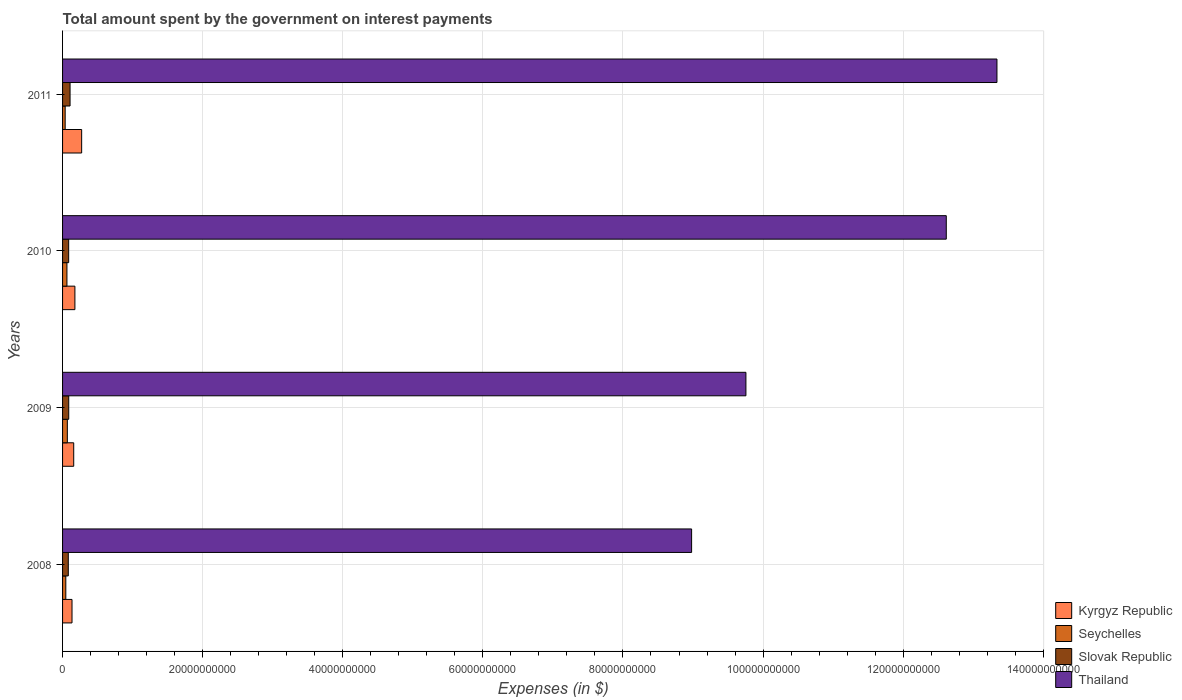Are the number of bars per tick equal to the number of legend labels?
Keep it short and to the point. Yes. Are the number of bars on each tick of the Y-axis equal?
Your response must be concise. Yes. What is the label of the 3rd group of bars from the top?
Your response must be concise. 2009. In how many cases, is the number of bars for a given year not equal to the number of legend labels?
Offer a terse response. 0. What is the amount spent on interest payments by the government in Seychelles in 2009?
Provide a succinct answer. 6.83e+08. Across all years, what is the maximum amount spent on interest payments by the government in Thailand?
Your answer should be very brief. 1.33e+11. Across all years, what is the minimum amount spent on interest payments by the government in Seychelles?
Your response must be concise. 3.72e+08. In which year was the amount spent on interest payments by the government in Seychelles minimum?
Your response must be concise. 2011. What is the total amount spent on interest payments by the government in Kyrgyz Republic in the graph?
Keep it short and to the point. 7.43e+09. What is the difference between the amount spent on interest payments by the government in Thailand in 2008 and that in 2009?
Keep it short and to the point. -7.75e+09. What is the difference between the amount spent on interest payments by the government in Kyrgyz Republic in 2010 and the amount spent on interest payments by the government in Slovak Republic in 2011?
Provide a short and direct response. 6.91e+08. What is the average amount spent on interest payments by the government in Slovak Republic per year?
Your answer should be compact. 9.10e+08. In the year 2008, what is the difference between the amount spent on interest payments by the government in Slovak Republic and amount spent on interest payments by the government in Kyrgyz Republic?
Make the answer very short. -5.30e+08. In how many years, is the amount spent on interest payments by the government in Kyrgyz Republic greater than 8000000000 $?
Your answer should be very brief. 0. What is the ratio of the amount spent on interest payments by the government in Kyrgyz Republic in 2009 to that in 2011?
Your answer should be very brief. 0.58. Is the difference between the amount spent on interest payments by the government in Slovak Republic in 2009 and 2010 greater than the difference between the amount spent on interest payments by the government in Kyrgyz Republic in 2009 and 2010?
Your answer should be very brief. Yes. What is the difference between the highest and the second highest amount spent on interest payments by the government in Slovak Republic?
Keep it short and to the point. 1.91e+08. What is the difference between the highest and the lowest amount spent on interest payments by the government in Thailand?
Give a very brief answer. 4.36e+1. Is the sum of the amount spent on interest payments by the government in Slovak Republic in 2009 and 2010 greater than the maximum amount spent on interest payments by the government in Kyrgyz Republic across all years?
Provide a short and direct response. No. Is it the case that in every year, the sum of the amount spent on interest payments by the government in Seychelles and amount spent on interest payments by the government in Thailand is greater than the sum of amount spent on interest payments by the government in Slovak Republic and amount spent on interest payments by the government in Kyrgyz Republic?
Your answer should be very brief. Yes. What does the 3rd bar from the top in 2010 represents?
Your answer should be compact. Seychelles. What does the 1st bar from the bottom in 2008 represents?
Your answer should be very brief. Kyrgyz Republic. Are all the bars in the graph horizontal?
Ensure brevity in your answer.  Yes. How many years are there in the graph?
Keep it short and to the point. 4. What is the difference between two consecutive major ticks on the X-axis?
Make the answer very short. 2.00e+1. Are the values on the major ticks of X-axis written in scientific E-notation?
Your response must be concise. No. Does the graph contain any zero values?
Provide a succinct answer. No. Does the graph contain grids?
Your answer should be very brief. Yes. What is the title of the graph?
Your answer should be very brief. Total amount spent by the government on interest payments. Does "Armenia" appear as one of the legend labels in the graph?
Your answer should be compact. No. What is the label or title of the X-axis?
Offer a very short reply. Expenses (in $). What is the Expenses (in $) of Kyrgyz Republic in 2008?
Offer a very short reply. 1.35e+09. What is the Expenses (in $) of Seychelles in 2008?
Provide a short and direct response. 4.64e+08. What is the Expenses (in $) in Slovak Republic in 2008?
Keep it short and to the point. 8.18e+08. What is the Expenses (in $) of Thailand in 2008?
Your answer should be very brief. 8.98e+1. What is the Expenses (in $) of Kyrgyz Republic in 2009?
Provide a succinct answer. 1.59e+09. What is the Expenses (in $) in Seychelles in 2009?
Provide a succinct answer. 6.83e+08. What is the Expenses (in $) of Slovak Republic in 2009?
Your response must be concise. 8.80e+08. What is the Expenses (in $) in Thailand in 2009?
Your response must be concise. 9.76e+1. What is the Expenses (in $) of Kyrgyz Republic in 2010?
Make the answer very short. 1.76e+09. What is the Expenses (in $) of Seychelles in 2010?
Your response must be concise. 6.25e+08. What is the Expenses (in $) of Slovak Republic in 2010?
Offer a very short reply. 8.71e+08. What is the Expenses (in $) of Thailand in 2010?
Provide a short and direct response. 1.26e+11. What is the Expenses (in $) of Kyrgyz Republic in 2011?
Your response must be concise. 2.73e+09. What is the Expenses (in $) of Seychelles in 2011?
Make the answer very short. 3.72e+08. What is the Expenses (in $) in Slovak Republic in 2011?
Provide a short and direct response. 1.07e+09. What is the Expenses (in $) in Thailand in 2011?
Give a very brief answer. 1.33e+11. Across all years, what is the maximum Expenses (in $) of Kyrgyz Republic?
Your answer should be very brief. 2.73e+09. Across all years, what is the maximum Expenses (in $) in Seychelles?
Your answer should be compact. 6.83e+08. Across all years, what is the maximum Expenses (in $) of Slovak Republic?
Offer a very short reply. 1.07e+09. Across all years, what is the maximum Expenses (in $) in Thailand?
Offer a terse response. 1.33e+11. Across all years, what is the minimum Expenses (in $) in Kyrgyz Republic?
Provide a short and direct response. 1.35e+09. Across all years, what is the minimum Expenses (in $) of Seychelles?
Offer a very short reply. 3.72e+08. Across all years, what is the minimum Expenses (in $) in Slovak Republic?
Your response must be concise. 8.18e+08. Across all years, what is the minimum Expenses (in $) of Thailand?
Provide a short and direct response. 8.98e+1. What is the total Expenses (in $) of Kyrgyz Republic in the graph?
Offer a terse response. 7.43e+09. What is the total Expenses (in $) in Seychelles in the graph?
Ensure brevity in your answer.  2.14e+09. What is the total Expenses (in $) in Slovak Republic in the graph?
Make the answer very short. 3.64e+09. What is the total Expenses (in $) of Thailand in the graph?
Make the answer very short. 4.47e+11. What is the difference between the Expenses (in $) of Kyrgyz Republic in 2008 and that in 2009?
Offer a terse response. -2.44e+08. What is the difference between the Expenses (in $) in Seychelles in 2008 and that in 2009?
Provide a short and direct response. -2.19e+08. What is the difference between the Expenses (in $) in Slovak Republic in 2008 and that in 2009?
Provide a short and direct response. -6.21e+07. What is the difference between the Expenses (in $) of Thailand in 2008 and that in 2009?
Offer a terse response. -7.75e+09. What is the difference between the Expenses (in $) of Kyrgyz Republic in 2008 and that in 2010?
Your answer should be very brief. -4.13e+08. What is the difference between the Expenses (in $) of Seychelles in 2008 and that in 2010?
Your response must be concise. -1.61e+08. What is the difference between the Expenses (in $) of Slovak Republic in 2008 and that in 2010?
Offer a terse response. -5.28e+07. What is the difference between the Expenses (in $) in Thailand in 2008 and that in 2010?
Your answer should be compact. -3.64e+1. What is the difference between the Expenses (in $) of Kyrgyz Republic in 2008 and that in 2011?
Keep it short and to the point. -1.38e+09. What is the difference between the Expenses (in $) in Seychelles in 2008 and that in 2011?
Offer a terse response. 9.21e+07. What is the difference between the Expenses (in $) in Slovak Republic in 2008 and that in 2011?
Keep it short and to the point. -2.53e+08. What is the difference between the Expenses (in $) in Thailand in 2008 and that in 2011?
Your answer should be compact. -4.36e+1. What is the difference between the Expenses (in $) in Kyrgyz Republic in 2009 and that in 2010?
Ensure brevity in your answer.  -1.69e+08. What is the difference between the Expenses (in $) in Seychelles in 2009 and that in 2010?
Your answer should be compact. 5.77e+07. What is the difference between the Expenses (in $) in Slovak Republic in 2009 and that in 2010?
Provide a short and direct response. 9.30e+06. What is the difference between the Expenses (in $) of Thailand in 2009 and that in 2010?
Your answer should be compact. -2.86e+1. What is the difference between the Expenses (in $) in Kyrgyz Republic in 2009 and that in 2011?
Your response must be concise. -1.13e+09. What is the difference between the Expenses (in $) in Seychelles in 2009 and that in 2011?
Keep it short and to the point. 3.11e+08. What is the difference between the Expenses (in $) in Slovak Republic in 2009 and that in 2011?
Your response must be concise. -1.91e+08. What is the difference between the Expenses (in $) in Thailand in 2009 and that in 2011?
Offer a terse response. -3.58e+1. What is the difference between the Expenses (in $) of Kyrgyz Republic in 2010 and that in 2011?
Offer a very short reply. -9.64e+08. What is the difference between the Expenses (in $) of Seychelles in 2010 and that in 2011?
Give a very brief answer. 2.53e+08. What is the difference between the Expenses (in $) of Slovak Republic in 2010 and that in 2011?
Your answer should be compact. -2.00e+08. What is the difference between the Expenses (in $) of Thailand in 2010 and that in 2011?
Provide a succinct answer. -7.23e+09. What is the difference between the Expenses (in $) of Kyrgyz Republic in 2008 and the Expenses (in $) of Seychelles in 2009?
Make the answer very short. 6.66e+08. What is the difference between the Expenses (in $) of Kyrgyz Republic in 2008 and the Expenses (in $) of Slovak Republic in 2009?
Give a very brief answer. 4.68e+08. What is the difference between the Expenses (in $) of Kyrgyz Republic in 2008 and the Expenses (in $) of Thailand in 2009?
Give a very brief answer. -9.62e+1. What is the difference between the Expenses (in $) in Seychelles in 2008 and the Expenses (in $) in Slovak Republic in 2009?
Provide a short and direct response. -4.16e+08. What is the difference between the Expenses (in $) of Seychelles in 2008 and the Expenses (in $) of Thailand in 2009?
Provide a succinct answer. -9.71e+1. What is the difference between the Expenses (in $) of Slovak Republic in 2008 and the Expenses (in $) of Thailand in 2009?
Ensure brevity in your answer.  -9.67e+1. What is the difference between the Expenses (in $) in Kyrgyz Republic in 2008 and the Expenses (in $) in Seychelles in 2010?
Give a very brief answer. 7.24e+08. What is the difference between the Expenses (in $) in Kyrgyz Republic in 2008 and the Expenses (in $) in Slovak Republic in 2010?
Your response must be concise. 4.78e+08. What is the difference between the Expenses (in $) of Kyrgyz Republic in 2008 and the Expenses (in $) of Thailand in 2010?
Your response must be concise. -1.25e+11. What is the difference between the Expenses (in $) of Seychelles in 2008 and the Expenses (in $) of Slovak Republic in 2010?
Your response must be concise. -4.07e+08. What is the difference between the Expenses (in $) of Seychelles in 2008 and the Expenses (in $) of Thailand in 2010?
Keep it short and to the point. -1.26e+11. What is the difference between the Expenses (in $) of Slovak Republic in 2008 and the Expenses (in $) of Thailand in 2010?
Offer a terse response. -1.25e+11. What is the difference between the Expenses (in $) in Kyrgyz Republic in 2008 and the Expenses (in $) in Seychelles in 2011?
Offer a very short reply. 9.77e+08. What is the difference between the Expenses (in $) of Kyrgyz Republic in 2008 and the Expenses (in $) of Slovak Republic in 2011?
Offer a terse response. 2.78e+08. What is the difference between the Expenses (in $) in Kyrgyz Republic in 2008 and the Expenses (in $) in Thailand in 2011?
Ensure brevity in your answer.  -1.32e+11. What is the difference between the Expenses (in $) in Seychelles in 2008 and the Expenses (in $) in Slovak Republic in 2011?
Offer a very short reply. -6.07e+08. What is the difference between the Expenses (in $) in Seychelles in 2008 and the Expenses (in $) in Thailand in 2011?
Provide a succinct answer. -1.33e+11. What is the difference between the Expenses (in $) in Slovak Republic in 2008 and the Expenses (in $) in Thailand in 2011?
Offer a very short reply. -1.33e+11. What is the difference between the Expenses (in $) in Kyrgyz Republic in 2009 and the Expenses (in $) in Seychelles in 2010?
Your response must be concise. 9.68e+08. What is the difference between the Expenses (in $) in Kyrgyz Republic in 2009 and the Expenses (in $) in Slovak Republic in 2010?
Your response must be concise. 7.22e+08. What is the difference between the Expenses (in $) of Kyrgyz Republic in 2009 and the Expenses (in $) of Thailand in 2010?
Keep it short and to the point. -1.25e+11. What is the difference between the Expenses (in $) in Seychelles in 2009 and the Expenses (in $) in Slovak Republic in 2010?
Provide a succinct answer. -1.88e+08. What is the difference between the Expenses (in $) of Seychelles in 2009 and the Expenses (in $) of Thailand in 2010?
Your answer should be compact. -1.25e+11. What is the difference between the Expenses (in $) in Slovak Republic in 2009 and the Expenses (in $) in Thailand in 2010?
Your answer should be compact. -1.25e+11. What is the difference between the Expenses (in $) of Kyrgyz Republic in 2009 and the Expenses (in $) of Seychelles in 2011?
Keep it short and to the point. 1.22e+09. What is the difference between the Expenses (in $) in Kyrgyz Republic in 2009 and the Expenses (in $) in Slovak Republic in 2011?
Offer a terse response. 5.22e+08. What is the difference between the Expenses (in $) in Kyrgyz Republic in 2009 and the Expenses (in $) in Thailand in 2011?
Ensure brevity in your answer.  -1.32e+11. What is the difference between the Expenses (in $) of Seychelles in 2009 and the Expenses (in $) of Slovak Republic in 2011?
Give a very brief answer. -3.88e+08. What is the difference between the Expenses (in $) in Seychelles in 2009 and the Expenses (in $) in Thailand in 2011?
Give a very brief answer. -1.33e+11. What is the difference between the Expenses (in $) in Slovak Republic in 2009 and the Expenses (in $) in Thailand in 2011?
Offer a terse response. -1.33e+11. What is the difference between the Expenses (in $) of Kyrgyz Republic in 2010 and the Expenses (in $) of Seychelles in 2011?
Give a very brief answer. 1.39e+09. What is the difference between the Expenses (in $) in Kyrgyz Republic in 2010 and the Expenses (in $) in Slovak Republic in 2011?
Your answer should be compact. 6.91e+08. What is the difference between the Expenses (in $) in Kyrgyz Republic in 2010 and the Expenses (in $) in Thailand in 2011?
Give a very brief answer. -1.32e+11. What is the difference between the Expenses (in $) of Seychelles in 2010 and the Expenses (in $) of Slovak Republic in 2011?
Your response must be concise. -4.46e+08. What is the difference between the Expenses (in $) in Seychelles in 2010 and the Expenses (in $) in Thailand in 2011?
Ensure brevity in your answer.  -1.33e+11. What is the difference between the Expenses (in $) in Slovak Republic in 2010 and the Expenses (in $) in Thailand in 2011?
Give a very brief answer. -1.33e+11. What is the average Expenses (in $) in Kyrgyz Republic per year?
Keep it short and to the point. 1.86e+09. What is the average Expenses (in $) in Seychelles per year?
Your response must be concise. 5.36e+08. What is the average Expenses (in $) of Slovak Republic per year?
Offer a very short reply. 9.10e+08. What is the average Expenses (in $) in Thailand per year?
Your answer should be compact. 1.12e+11. In the year 2008, what is the difference between the Expenses (in $) in Kyrgyz Republic and Expenses (in $) in Seychelles?
Provide a short and direct response. 8.85e+08. In the year 2008, what is the difference between the Expenses (in $) in Kyrgyz Republic and Expenses (in $) in Slovak Republic?
Keep it short and to the point. 5.30e+08. In the year 2008, what is the difference between the Expenses (in $) of Kyrgyz Republic and Expenses (in $) of Thailand?
Your answer should be very brief. -8.85e+1. In the year 2008, what is the difference between the Expenses (in $) in Seychelles and Expenses (in $) in Slovak Republic?
Your response must be concise. -3.54e+08. In the year 2008, what is the difference between the Expenses (in $) in Seychelles and Expenses (in $) in Thailand?
Give a very brief answer. -8.93e+1. In the year 2008, what is the difference between the Expenses (in $) of Slovak Republic and Expenses (in $) of Thailand?
Offer a terse response. -8.90e+1. In the year 2009, what is the difference between the Expenses (in $) of Kyrgyz Republic and Expenses (in $) of Seychelles?
Your answer should be very brief. 9.10e+08. In the year 2009, what is the difference between the Expenses (in $) of Kyrgyz Republic and Expenses (in $) of Slovak Republic?
Your answer should be compact. 7.12e+08. In the year 2009, what is the difference between the Expenses (in $) of Kyrgyz Republic and Expenses (in $) of Thailand?
Offer a terse response. -9.60e+1. In the year 2009, what is the difference between the Expenses (in $) in Seychelles and Expenses (in $) in Slovak Republic?
Your response must be concise. -1.97e+08. In the year 2009, what is the difference between the Expenses (in $) in Seychelles and Expenses (in $) in Thailand?
Give a very brief answer. -9.69e+1. In the year 2009, what is the difference between the Expenses (in $) of Slovak Republic and Expenses (in $) of Thailand?
Give a very brief answer. -9.67e+1. In the year 2010, what is the difference between the Expenses (in $) of Kyrgyz Republic and Expenses (in $) of Seychelles?
Ensure brevity in your answer.  1.14e+09. In the year 2010, what is the difference between the Expenses (in $) of Kyrgyz Republic and Expenses (in $) of Slovak Republic?
Your answer should be compact. 8.90e+08. In the year 2010, what is the difference between the Expenses (in $) in Kyrgyz Republic and Expenses (in $) in Thailand?
Provide a short and direct response. -1.24e+11. In the year 2010, what is the difference between the Expenses (in $) in Seychelles and Expenses (in $) in Slovak Republic?
Provide a short and direct response. -2.46e+08. In the year 2010, what is the difference between the Expenses (in $) in Seychelles and Expenses (in $) in Thailand?
Offer a very short reply. -1.26e+11. In the year 2010, what is the difference between the Expenses (in $) in Slovak Republic and Expenses (in $) in Thailand?
Give a very brief answer. -1.25e+11. In the year 2011, what is the difference between the Expenses (in $) in Kyrgyz Republic and Expenses (in $) in Seychelles?
Your response must be concise. 2.35e+09. In the year 2011, what is the difference between the Expenses (in $) of Kyrgyz Republic and Expenses (in $) of Slovak Republic?
Your answer should be compact. 1.65e+09. In the year 2011, what is the difference between the Expenses (in $) of Kyrgyz Republic and Expenses (in $) of Thailand?
Your answer should be compact. -1.31e+11. In the year 2011, what is the difference between the Expenses (in $) in Seychelles and Expenses (in $) in Slovak Republic?
Your answer should be compact. -6.99e+08. In the year 2011, what is the difference between the Expenses (in $) of Seychelles and Expenses (in $) of Thailand?
Make the answer very short. -1.33e+11. In the year 2011, what is the difference between the Expenses (in $) in Slovak Republic and Expenses (in $) in Thailand?
Offer a very short reply. -1.32e+11. What is the ratio of the Expenses (in $) in Kyrgyz Republic in 2008 to that in 2009?
Provide a short and direct response. 0.85. What is the ratio of the Expenses (in $) of Seychelles in 2008 to that in 2009?
Make the answer very short. 0.68. What is the ratio of the Expenses (in $) of Slovak Republic in 2008 to that in 2009?
Give a very brief answer. 0.93. What is the ratio of the Expenses (in $) of Thailand in 2008 to that in 2009?
Your response must be concise. 0.92. What is the ratio of the Expenses (in $) in Kyrgyz Republic in 2008 to that in 2010?
Ensure brevity in your answer.  0.77. What is the ratio of the Expenses (in $) of Seychelles in 2008 to that in 2010?
Give a very brief answer. 0.74. What is the ratio of the Expenses (in $) of Slovak Republic in 2008 to that in 2010?
Provide a short and direct response. 0.94. What is the ratio of the Expenses (in $) in Thailand in 2008 to that in 2010?
Your answer should be very brief. 0.71. What is the ratio of the Expenses (in $) of Kyrgyz Republic in 2008 to that in 2011?
Offer a terse response. 0.49. What is the ratio of the Expenses (in $) of Seychelles in 2008 to that in 2011?
Offer a very short reply. 1.25. What is the ratio of the Expenses (in $) in Slovak Republic in 2008 to that in 2011?
Your answer should be very brief. 0.76. What is the ratio of the Expenses (in $) in Thailand in 2008 to that in 2011?
Offer a very short reply. 0.67. What is the ratio of the Expenses (in $) of Kyrgyz Republic in 2009 to that in 2010?
Offer a very short reply. 0.9. What is the ratio of the Expenses (in $) in Seychelles in 2009 to that in 2010?
Offer a terse response. 1.09. What is the ratio of the Expenses (in $) of Slovak Republic in 2009 to that in 2010?
Your answer should be very brief. 1.01. What is the ratio of the Expenses (in $) of Thailand in 2009 to that in 2010?
Keep it short and to the point. 0.77. What is the ratio of the Expenses (in $) in Kyrgyz Republic in 2009 to that in 2011?
Keep it short and to the point. 0.58. What is the ratio of the Expenses (in $) of Seychelles in 2009 to that in 2011?
Offer a terse response. 1.84. What is the ratio of the Expenses (in $) in Slovak Republic in 2009 to that in 2011?
Provide a short and direct response. 0.82. What is the ratio of the Expenses (in $) in Thailand in 2009 to that in 2011?
Your answer should be very brief. 0.73. What is the ratio of the Expenses (in $) in Kyrgyz Republic in 2010 to that in 2011?
Provide a short and direct response. 0.65. What is the ratio of the Expenses (in $) in Seychelles in 2010 to that in 2011?
Keep it short and to the point. 1.68. What is the ratio of the Expenses (in $) in Slovak Republic in 2010 to that in 2011?
Provide a short and direct response. 0.81. What is the ratio of the Expenses (in $) of Thailand in 2010 to that in 2011?
Ensure brevity in your answer.  0.95. What is the difference between the highest and the second highest Expenses (in $) in Kyrgyz Republic?
Ensure brevity in your answer.  9.64e+08. What is the difference between the highest and the second highest Expenses (in $) of Seychelles?
Offer a very short reply. 5.77e+07. What is the difference between the highest and the second highest Expenses (in $) of Slovak Republic?
Your answer should be very brief. 1.91e+08. What is the difference between the highest and the second highest Expenses (in $) in Thailand?
Keep it short and to the point. 7.23e+09. What is the difference between the highest and the lowest Expenses (in $) in Kyrgyz Republic?
Offer a very short reply. 1.38e+09. What is the difference between the highest and the lowest Expenses (in $) of Seychelles?
Ensure brevity in your answer.  3.11e+08. What is the difference between the highest and the lowest Expenses (in $) of Slovak Republic?
Keep it short and to the point. 2.53e+08. What is the difference between the highest and the lowest Expenses (in $) of Thailand?
Keep it short and to the point. 4.36e+1. 